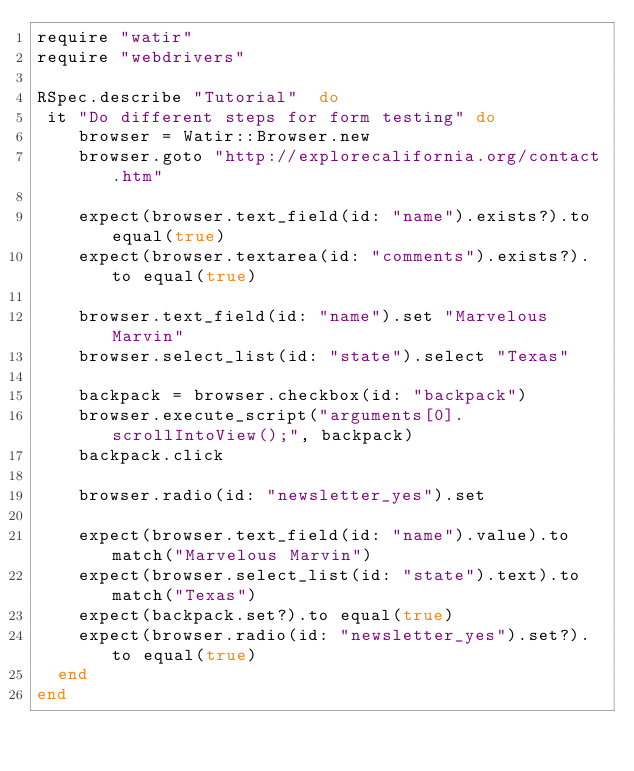<code> <loc_0><loc_0><loc_500><loc_500><_Ruby_>require "watir"
require "webdrivers"

RSpec.describe "Tutorial"  do
 it "Do different steps for form testing" do
    browser = Watir::Browser.new
    browser.goto "http://explorecalifornia.org/contact.htm"

    expect(browser.text_field(id: "name").exists?).to equal(true)
    expect(browser.textarea(id: "comments").exists?).to equal(true)

    browser.text_field(id: "name").set "Marvelous Marvin"
    browser.select_list(id: "state").select "Texas"

    backpack = browser.checkbox(id: "backpack")
    browser.execute_script("arguments[0].scrollIntoView();", backpack)
    backpack.click

    browser.radio(id: "newsletter_yes").set

    expect(browser.text_field(id: "name").value).to match("Marvelous Marvin")
    expect(browser.select_list(id: "state").text).to match("Texas")
    expect(backpack.set?).to equal(true)
    expect(browser.radio(id: "newsletter_yes").set?).to equal(true)
  end
end</code> 